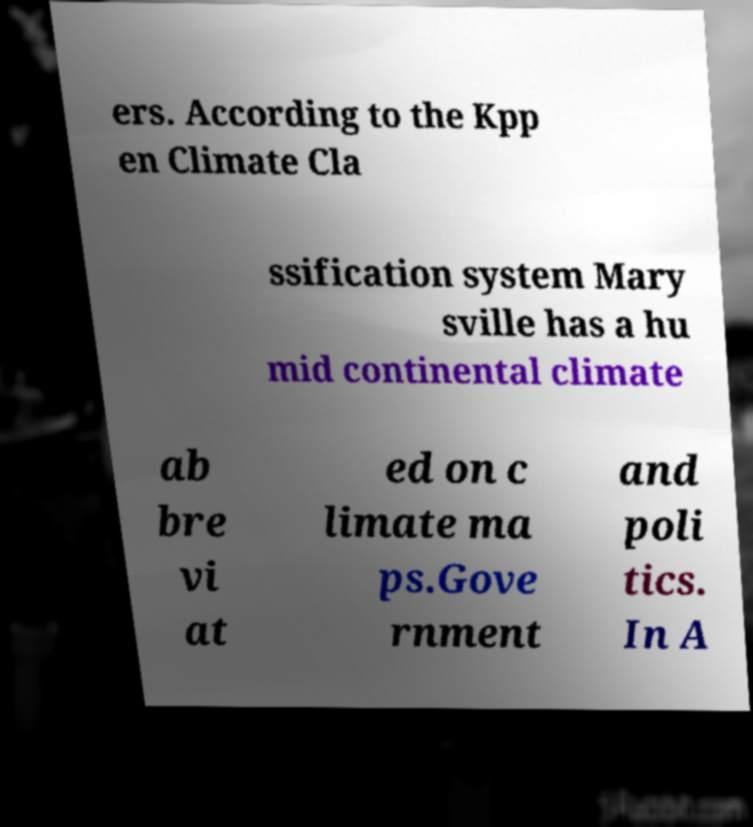Can you accurately transcribe the text from the provided image for me? ers. According to the Kpp en Climate Cla ssification system Mary sville has a hu mid continental climate ab bre vi at ed on c limate ma ps.Gove rnment and poli tics. In A 